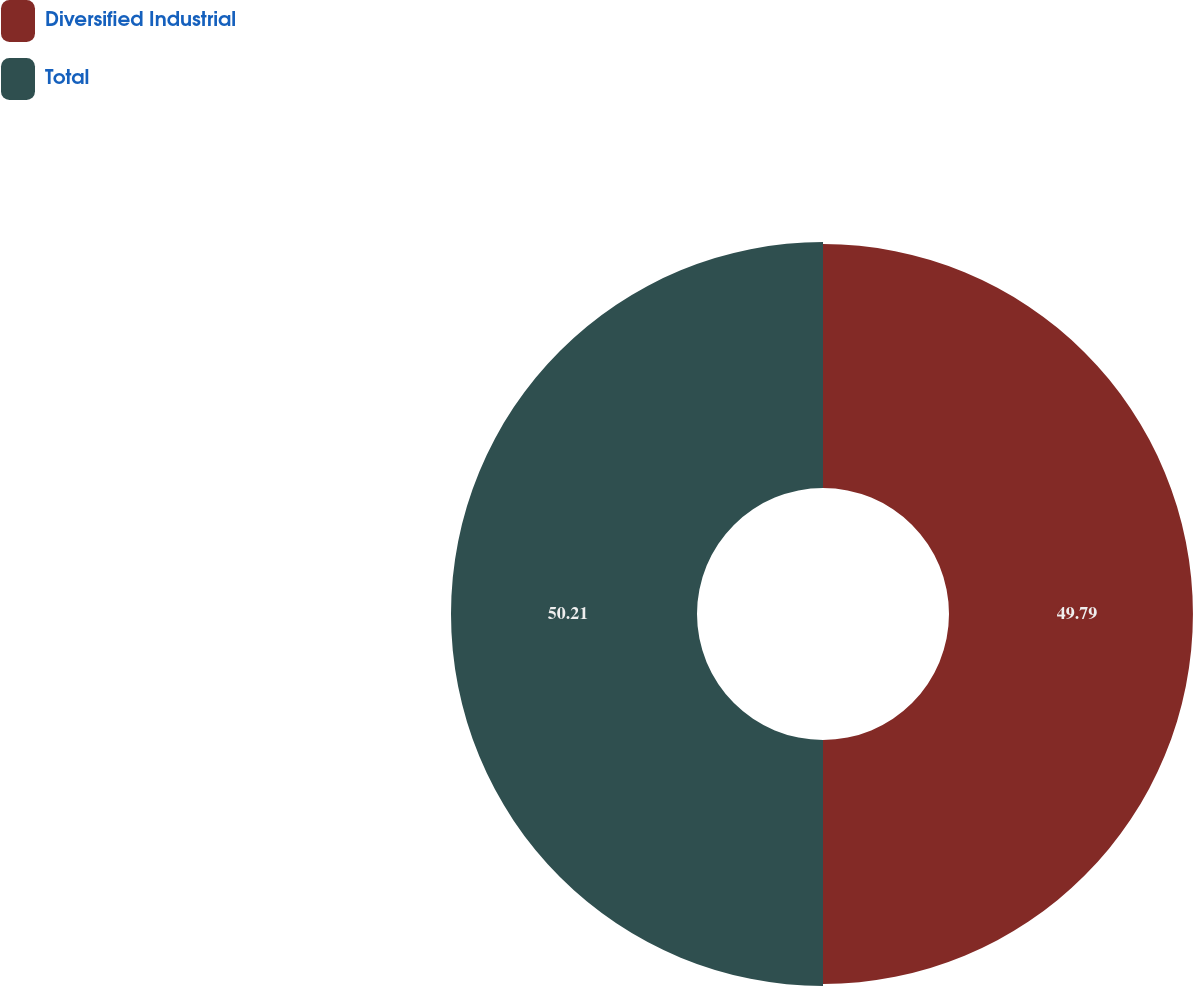<chart> <loc_0><loc_0><loc_500><loc_500><pie_chart><fcel>Diversified Industrial<fcel>Total<nl><fcel>49.79%<fcel>50.21%<nl></chart> 